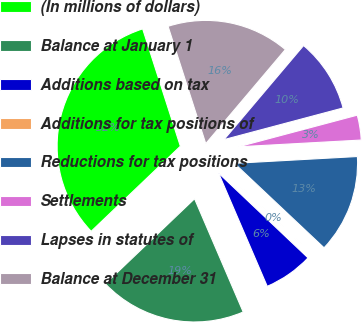Convert chart. <chart><loc_0><loc_0><loc_500><loc_500><pie_chart><fcel>(In millions of dollars)<fcel>Balance at January 1<fcel>Additions based on tax<fcel>Additions for tax positions of<fcel>Reductions for tax positions<fcel>Settlements<fcel>Lapses in statutes of<fcel>Balance at December 31<nl><fcel>32.18%<fcel>19.33%<fcel>6.47%<fcel>0.05%<fcel>12.9%<fcel>3.26%<fcel>9.69%<fcel>16.12%<nl></chart> 